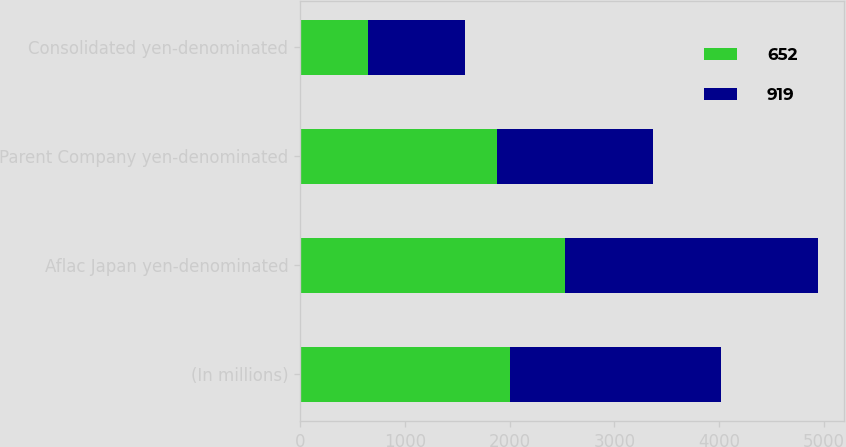Convert chart to OTSL. <chart><loc_0><loc_0><loc_500><loc_500><stacked_bar_chart><ecel><fcel>(In millions)<fcel>Aflac Japan yen-denominated<fcel>Parent Company yen-denominated<fcel>Consolidated yen-denominated<nl><fcel>652<fcel>2008<fcel>2528<fcel>1876<fcel>652<nl><fcel>919<fcel>2007<fcel>2415<fcel>1496<fcel>919<nl></chart> 